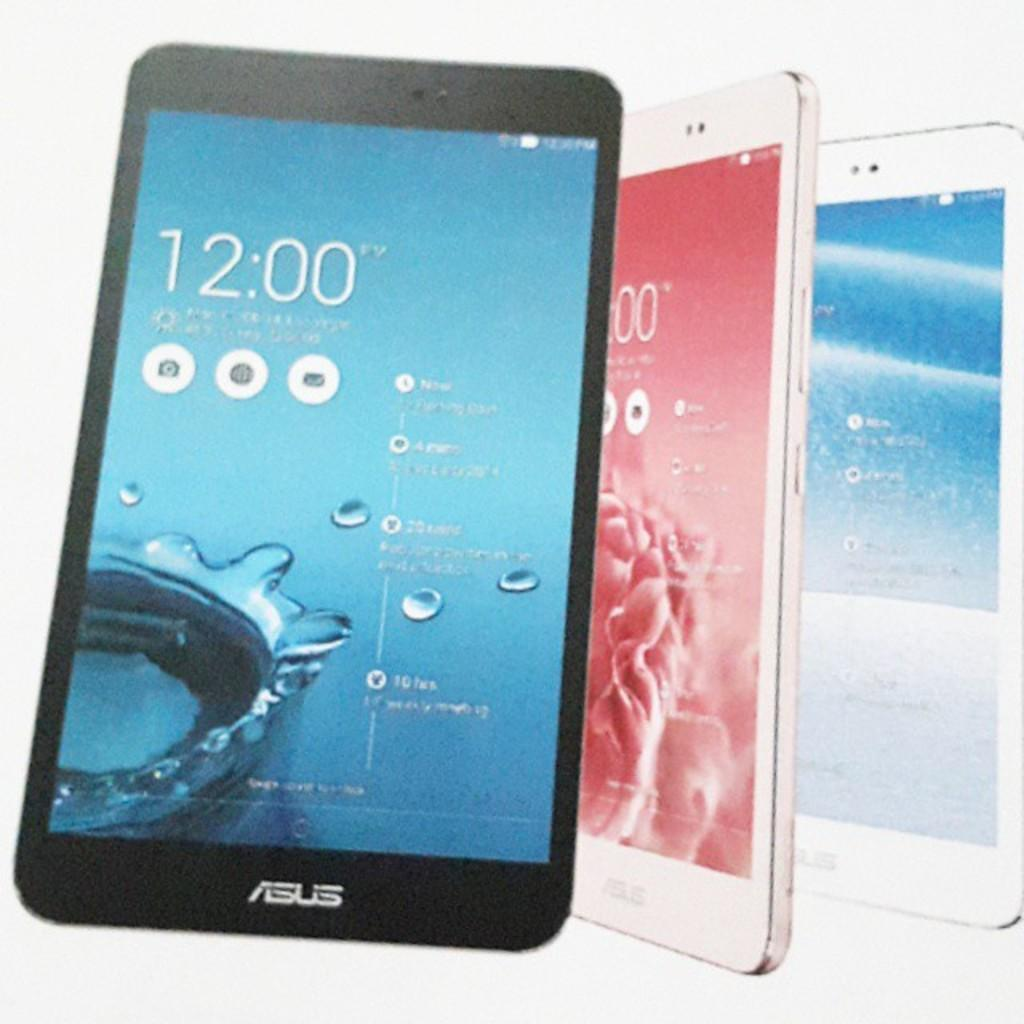What type of objects are present in the image? There are mobiles in the image. Is there any text visible in the image? Yes, there is some text visible in the image. What else can be seen in the image besides mobiles and text? Water drops and applications are present in the image. Where is the store located in the image? There is no store present in the image. How many times does the calendar appear in the image? There is no calendar present in the image. 